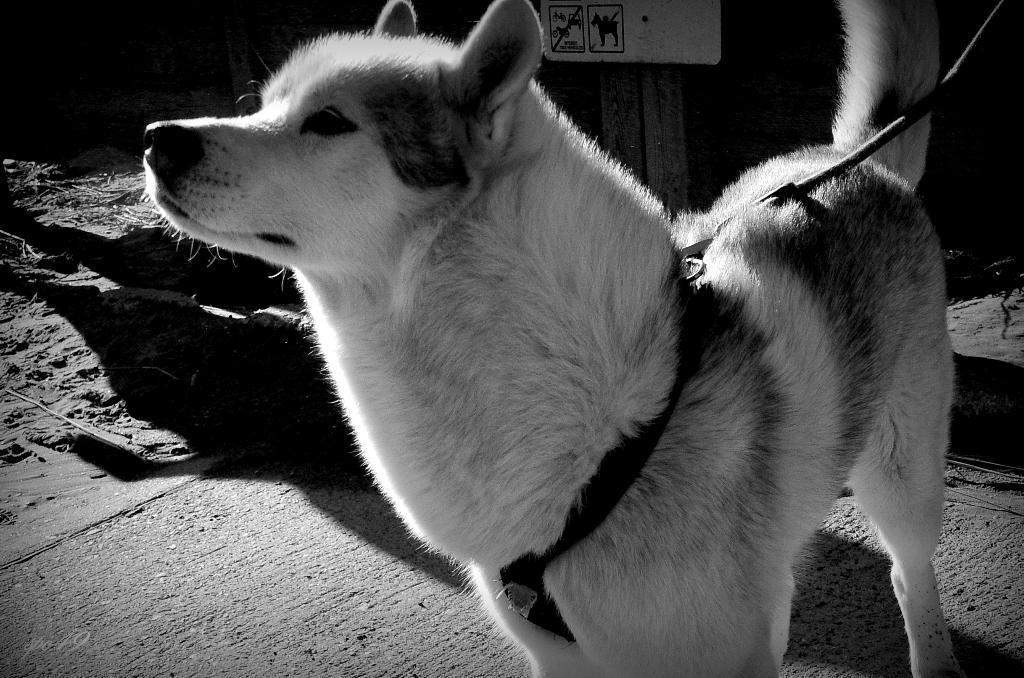Could you give a brief overview of what you see in this image? In this picture we can see a dog on the ground with a belt on it and in the background we can see a board. 